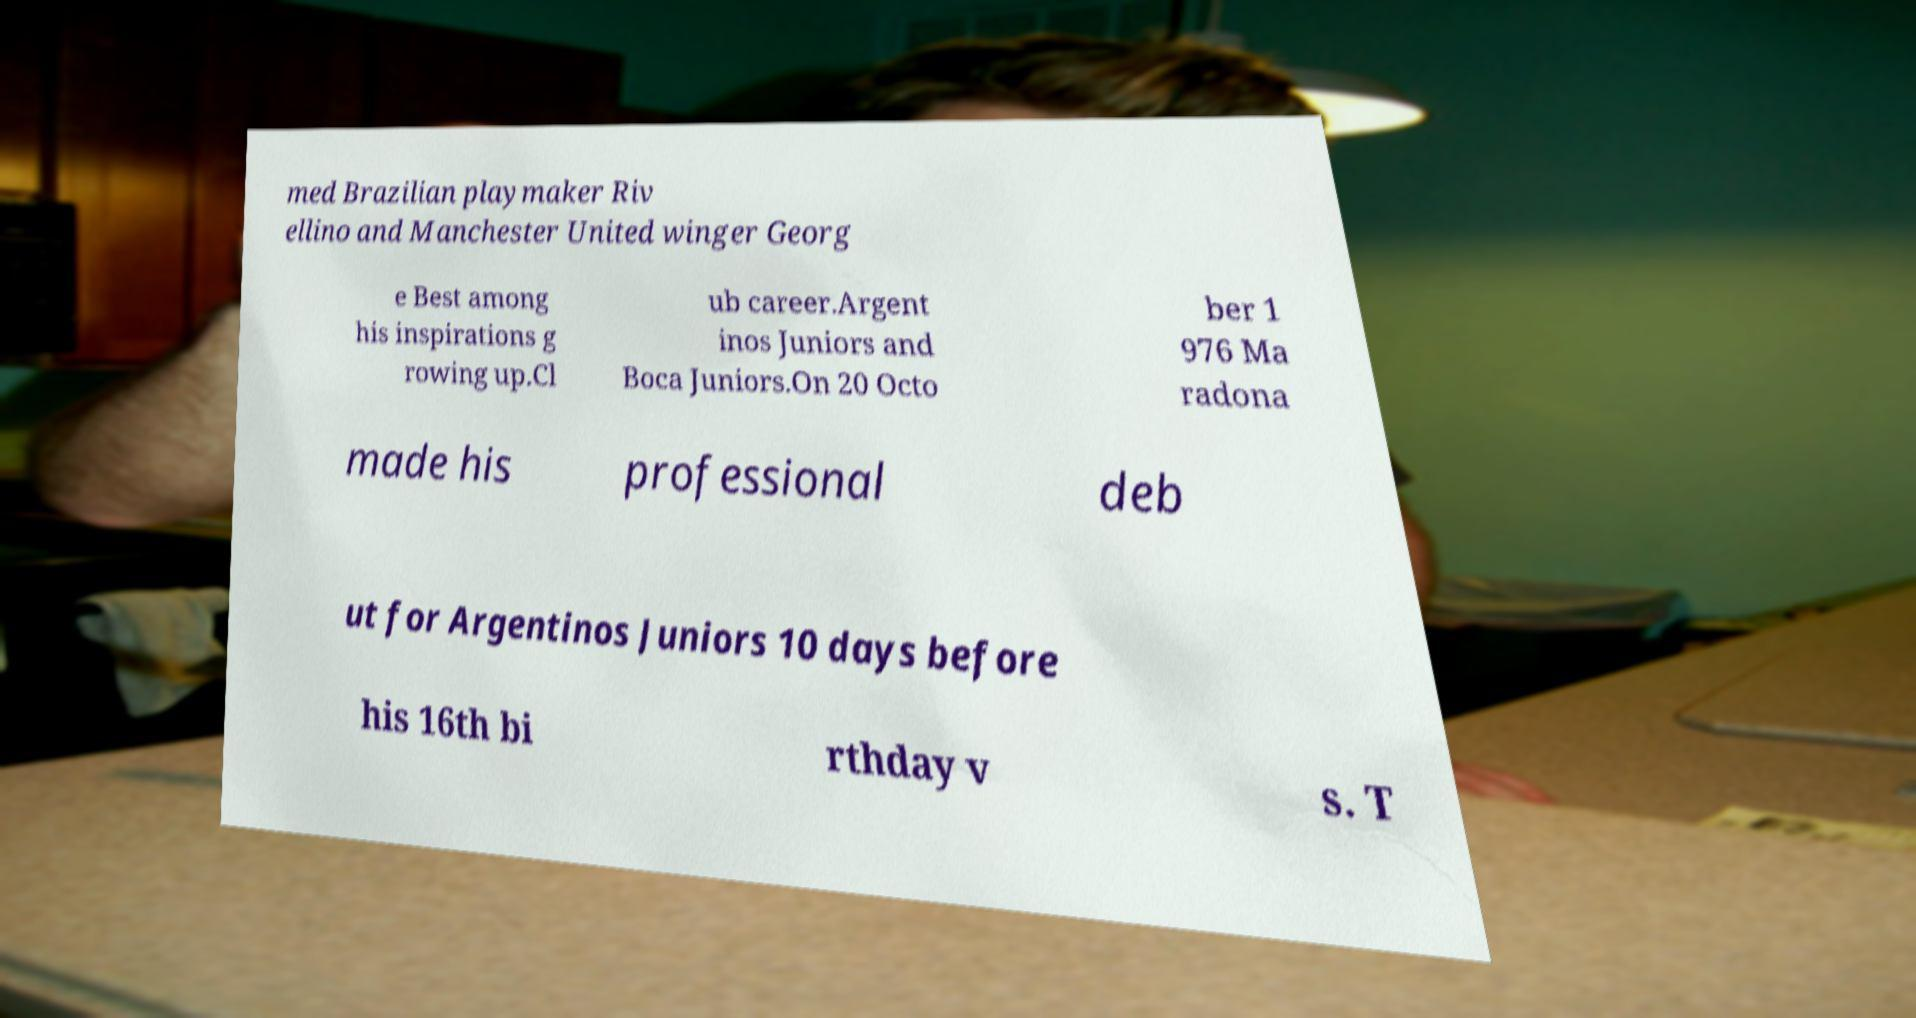Could you assist in decoding the text presented in this image and type it out clearly? med Brazilian playmaker Riv ellino and Manchester United winger Georg e Best among his inspirations g rowing up.Cl ub career.Argent inos Juniors and Boca Juniors.On 20 Octo ber 1 976 Ma radona made his professional deb ut for Argentinos Juniors 10 days before his 16th bi rthday v s. T 